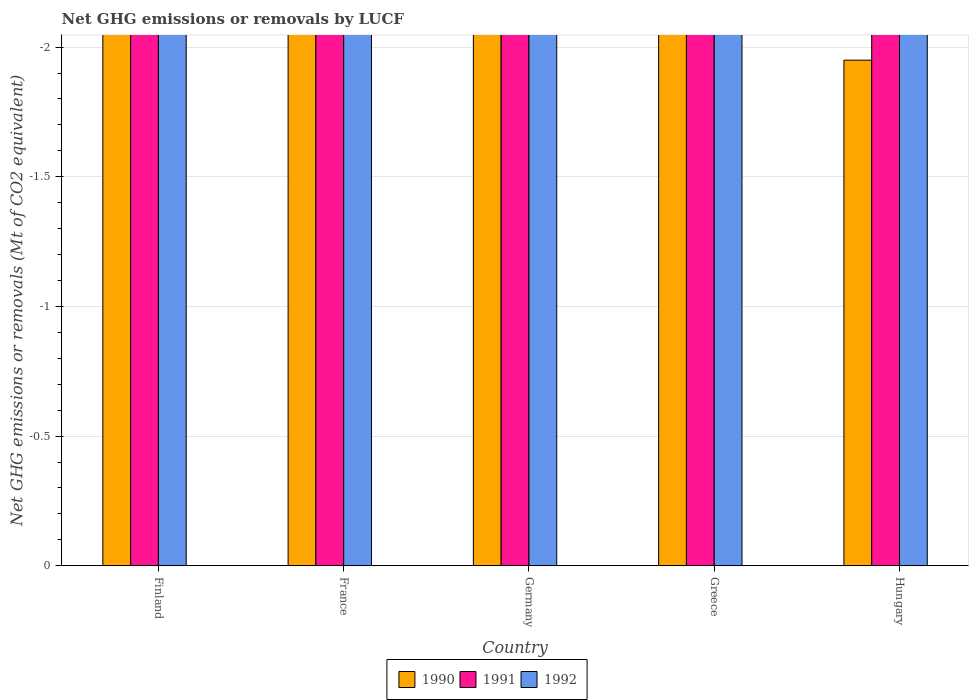How many different coloured bars are there?
Keep it short and to the point. 0. Are the number of bars per tick equal to the number of legend labels?
Your response must be concise. No. Are the number of bars on each tick of the X-axis equal?
Provide a succinct answer. Yes. What is the label of the 2nd group of bars from the left?
Keep it short and to the point. France. In how many cases, is the number of bars for a given country not equal to the number of legend labels?
Offer a terse response. 5. What is the net GHG emissions or removals by LUCF in 1991 in Greece?
Provide a succinct answer. 0. Across all countries, what is the minimum net GHG emissions or removals by LUCF in 1992?
Your answer should be very brief. 0. What is the average net GHG emissions or removals by LUCF in 1990 per country?
Ensure brevity in your answer.  0. In how many countries, is the net GHG emissions or removals by LUCF in 1990 greater than -0.7 Mt?
Provide a short and direct response. 0. Is it the case that in every country, the sum of the net GHG emissions or removals by LUCF in 1990 and net GHG emissions or removals by LUCF in 1992 is greater than the net GHG emissions or removals by LUCF in 1991?
Your answer should be very brief. No. How many bars are there?
Ensure brevity in your answer.  0. Are the values on the major ticks of Y-axis written in scientific E-notation?
Offer a very short reply. No. Where does the legend appear in the graph?
Offer a very short reply. Bottom center. How many legend labels are there?
Offer a terse response. 3. How are the legend labels stacked?
Offer a terse response. Horizontal. What is the title of the graph?
Give a very brief answer. Net GHG emissions or removals by LUCF. Does "1999" appear as one of the legend labels in the graph?
Ensure brevity in your answer.  No. What is the label or title of the X-axis?
Your answer should be compact. Country. What is the label or title of the Y-axis?
Your answer should be very brief. Net GHG emissions or removals (Mt of CO2 equivalent). What is the Net GHG emissions or removals (Mt of CO2 equivalent) in 1990 in Finland?
Offer a terse response. 0. What is the Net GHG emissions or removals (Mt of CO2 equivalent) in 1991 in Finland?
Provide a short and direct response. 0. What is the Net GHG emissions or removals (Mt of CO2 equivalent) in 1992 in Finland?
Provide a short and direct response. 0. What is the Net GHG emissions or removals (Mt of CO2 equivalent) of 1991 in France?
Offer a very short reply. 0. What is the Net GHG emissions or removals (Mt of CO2 equivalent) of 1992 in France?
Make the answer very short. 0. What is the Net GHG emissions or removals (Mt of CO2 equivalent) in 1990 in Germany?
Provide a short and direct response. 0. What is the Net GHG emissions or removals (Mt of CO2 equivalent) of 1991 in Greece?
Keep it short and to the point. 0. What is the Net GHG emissions or removals (Mt of CO2 equivalent) of 1992 in Hungary?
Ensure brevity in your answer.  0. What is the average Net GHG emissions or removals (Mt of CO2 equivalent) of 1990 per country?
Provide a succinct answer. 0. What is the average Net GHG emissions or removals (Mt of CO2 equivalent) in 1992 per country?
Offer a terse response. 0. 